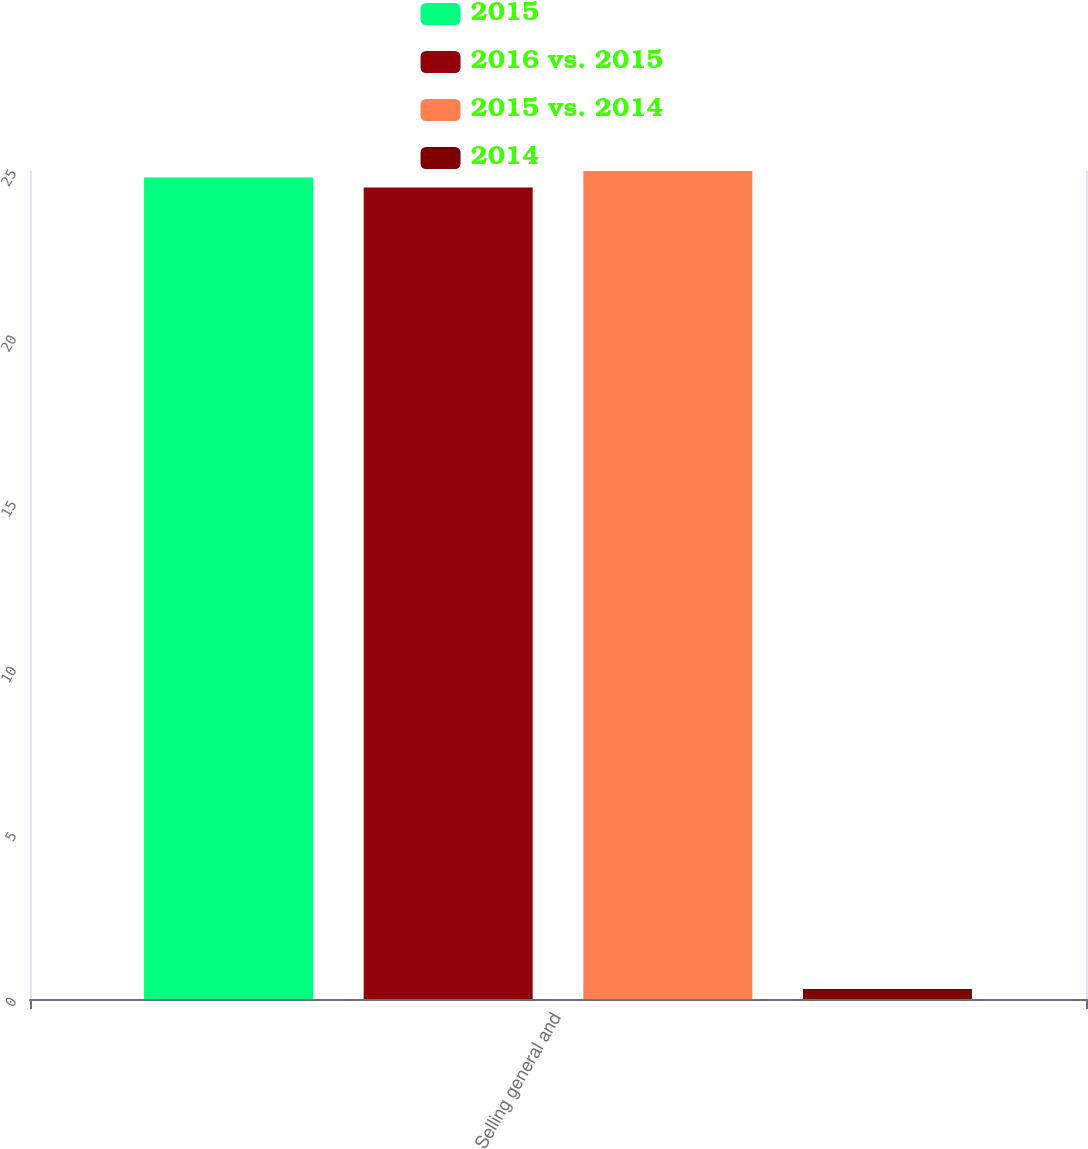<chart> <loc_0><loc_0><loc_500><loc_500><stacked_bar_chart><ecel><fcel>Selling general and<nl><fcel>2015<fcel>24.8<nl><fcel>2016 vs. 2015<fcel>24.5<nl><fcel>2015 vs. 2014<fcel>25<nl><fcel>2014<fcel>0.3<nl></chart> 